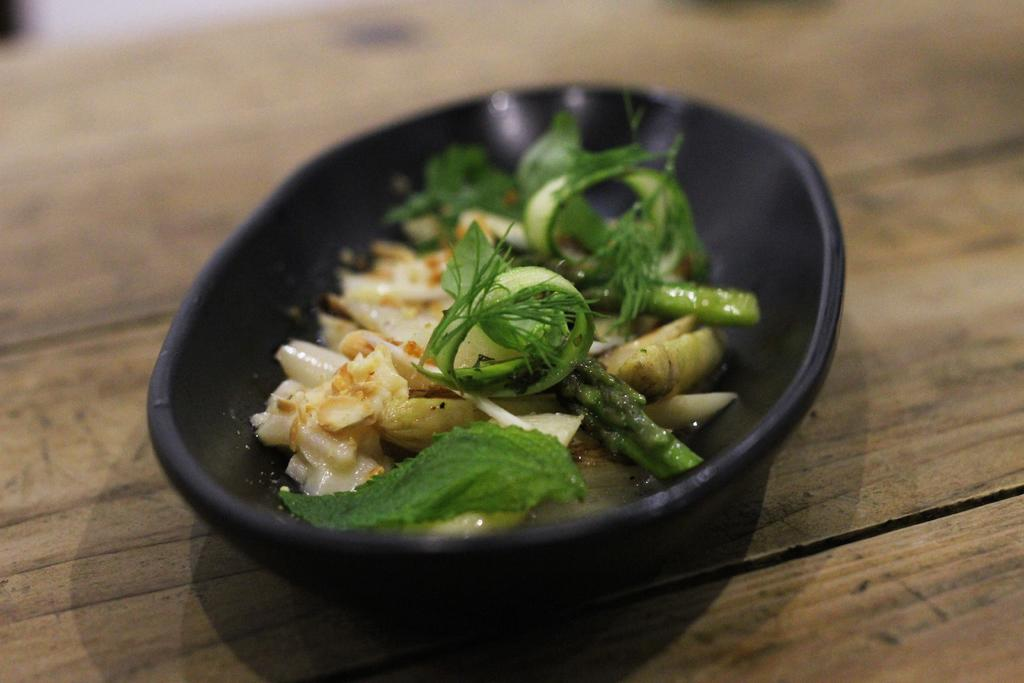What type of food is visible in the image? There is cooked food in the image. How is the cooked food being served? The cooked food is served in a bowl. Where is the bowl with cooked food located? The bowl with cooked food is placed on a table. What type of crib can be seen in the image? There is no crib present in the image. How many months does the basin in the image represent? There is no basin present in the image. 